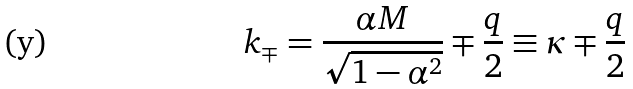<formula> <loc_0><loc_0><loc_500><loc_500>k _ { \mp } = { \frac { \alpha M } { \sqrt { 1 - \alpha ^ { 2 } } } } \mp { \frac { q } { 2 } } \equiv \kappa \mp { \frac { q } { 2 } }</formula> 